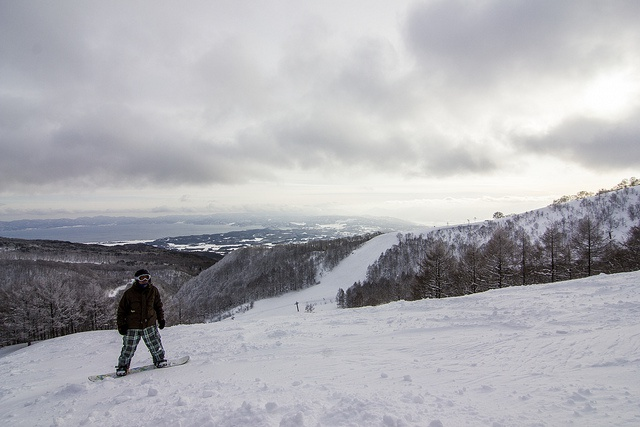Describe the objects in this image and their specific colors. I can see people in darkgray, black, and gray tones and snowboard in darkgray, gray, and black tones in this image. 